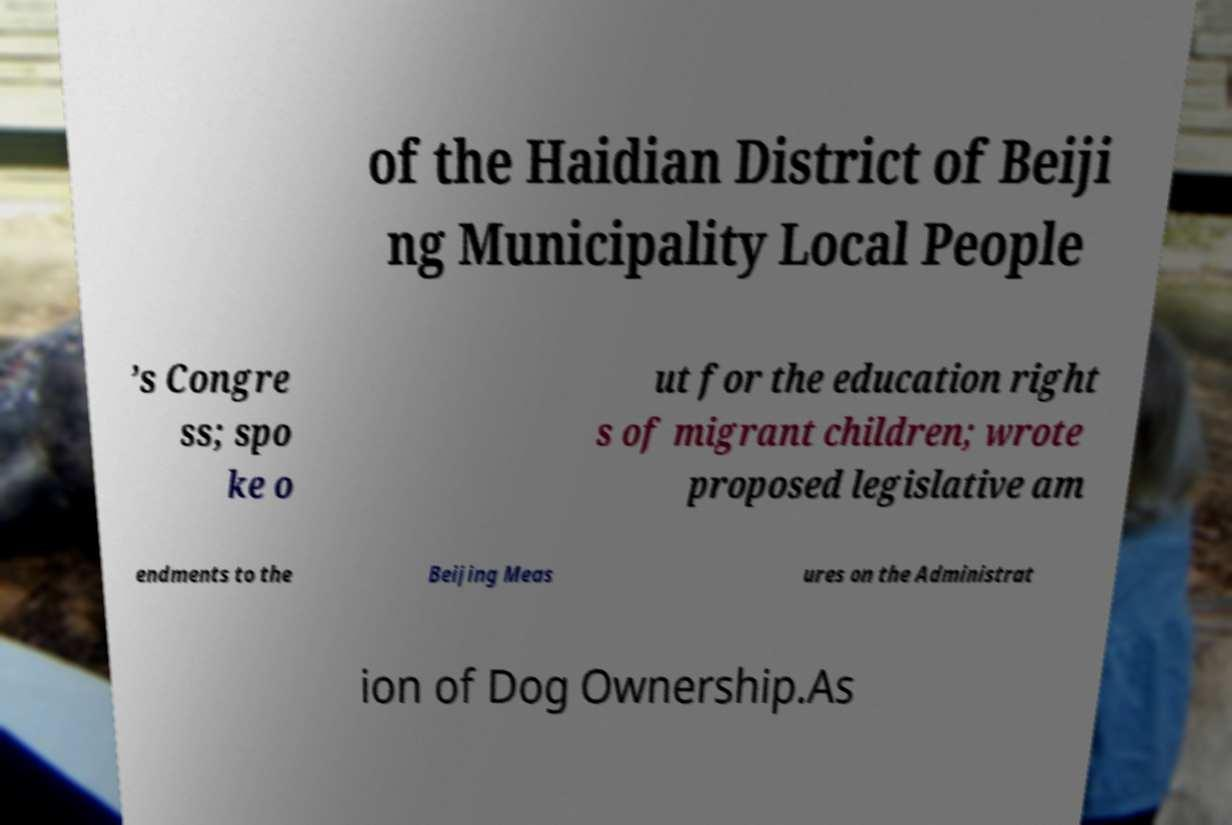Could you assist in decoding the text presented in this image and type it out clearly? of the Haidian District of Beiji ng Municipality Local People ’s Congre ss; spo ke o ut for the education right s of migrant children; wrote proposed legislative am endments to the Beijing Meas ures on the Administrat ion of Dog Ownership.As 